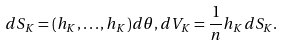<formula> <loc_0><loc_0><loc_500><loc_500>d S _ { K } = ( h _ { K } , \dots , h _ { K } ) d \theta , d V _ { K } = \frac { 1 } { n } h _ { K } d S _ { K } .</formula> 